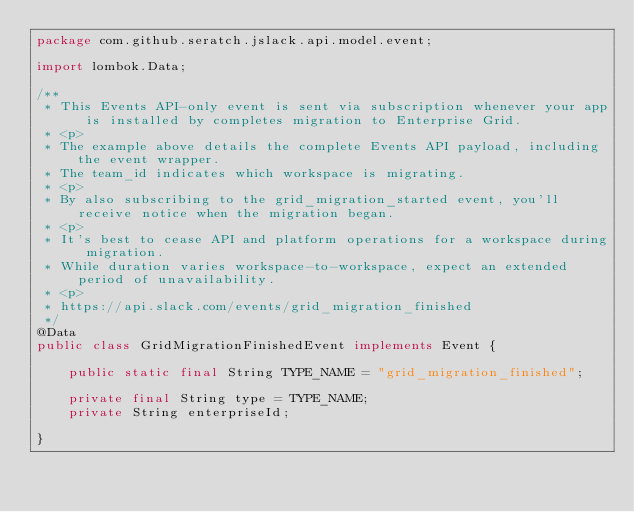Convert code to text. <code><loc_0><loc_0><loc_500><loc_500><_Java_>package com.github.seratch.jslack.api.model.event;

import lombok.Data;

/**
 * This Events API-only event is sent via subscription whenever your app is installed by completes migration to Enterprise Grid.
 * <p>
 * The example above details the complete Events API payload, including the event wrapper.
 * The team_id indicates which workspace is migrating.
 * <p>
 * By also subscribing to the grid_migration_started event, you'll receive notice when the migration began.
 * <p>
 * It's best to cease API and platform operations for a workspace during migration.
 * While duration varies workspace-to-workspace, expect an extended period of unavailability.
 * <p>
 * https://api.slack.com/events/grid_migration_finished
 */
@Data
public class GridMigrationFinishedEvent implements Event {

    public static final String TYPE_NAME = "grid_migration_finished";

    private final String type = TYPE_NAME;
    private String enterpriseId;

}</code> 